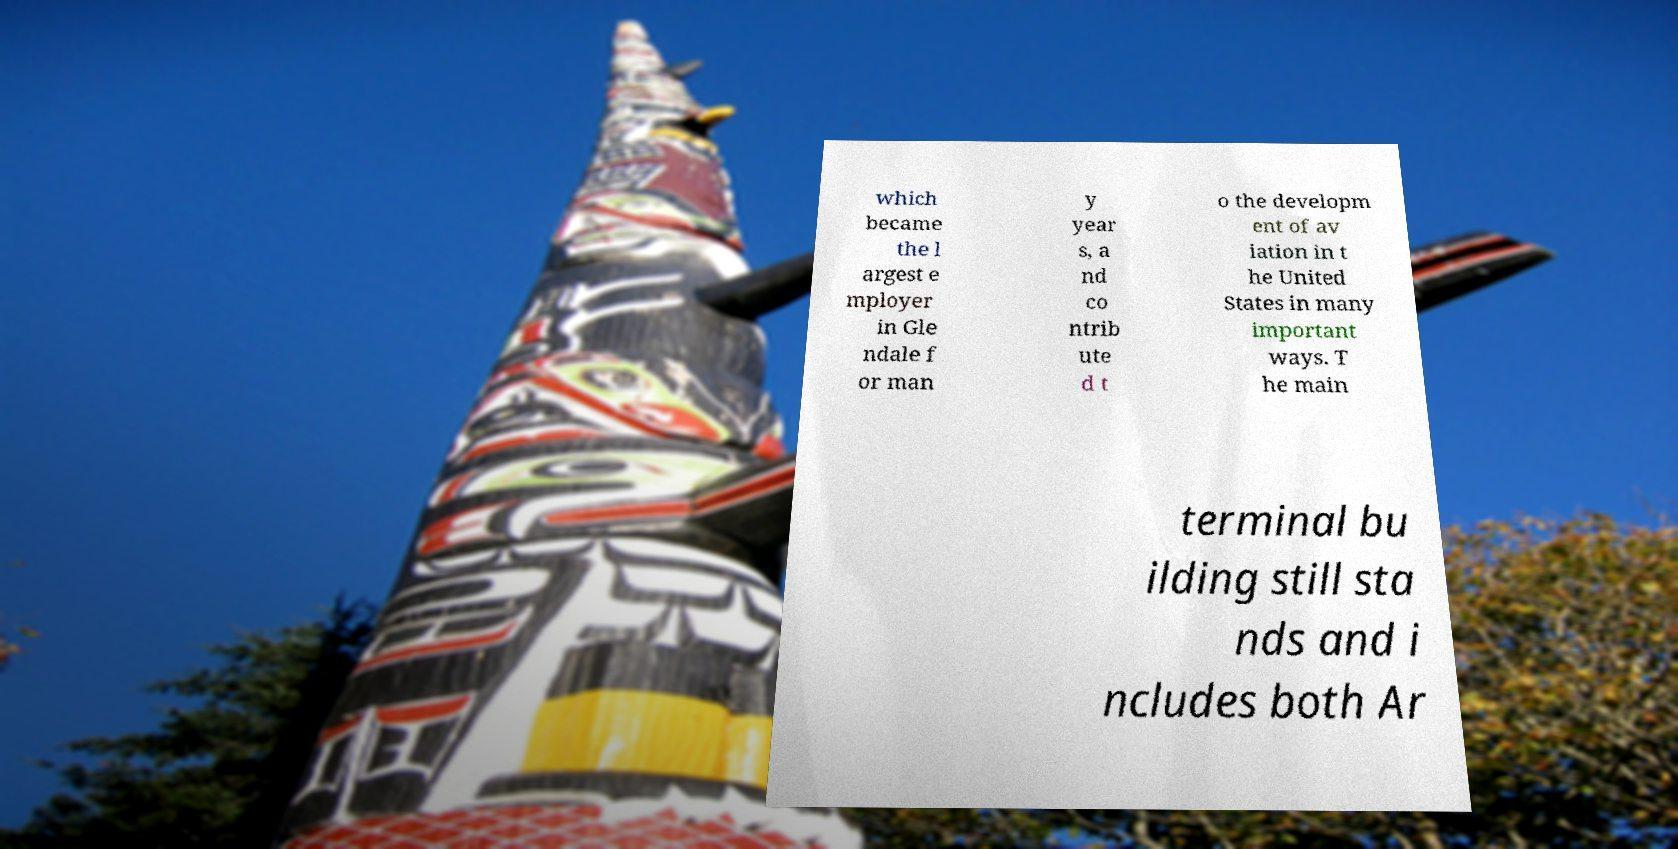I need the written content from this picture converted into text. Can you do that? which became the l argest e mployer in Gle ndale f or man y year s, a nd co ntrib ute d t o the developm ent of av iation in t he United States in many important ways. T he main terminal bu ilding still sta nds and i ncludes both Ar 